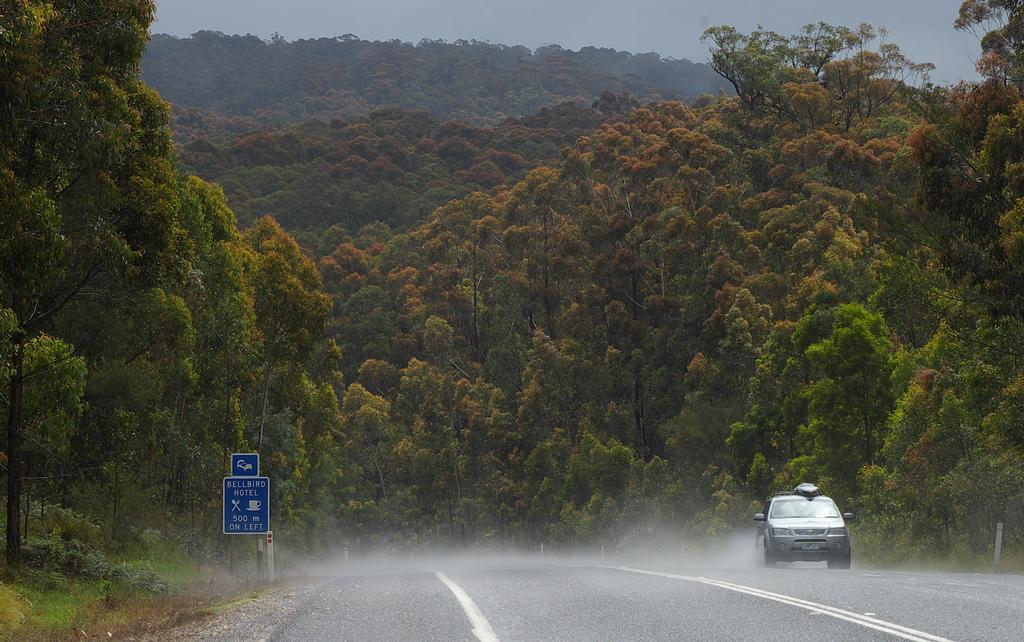In one or two sentences, can you explain what this image depicts? This is an outside view. At the bottom of the image I can see a car on the road. There is a blue color board is placed beside this road. In the background I can see the trees. On the top of the image I can see the sky. 